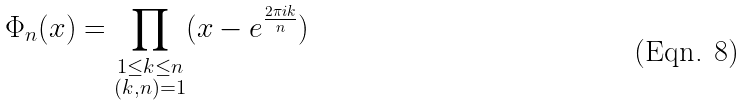<formula> <loc_0><loc_0><loc_500><loc_500>\Phi _ { n } ( x ) = \prod _ { \substack { 1 \leq k \leq n \\ ( k , n ) = 1 } } ( x - e ^ { \frac { 2 \pi i k } { n } } )</formula> 